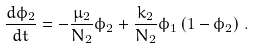<formula> <loc_0><loc_0><loc_500><loc_500>\frac { d \phi _ { 2 } } { d t } = - \frac { \mu _ { 2 } } { N _ { 2 } } \phi _ { 2 } + \frac { k _ { 2 } } { N _ { 2 } } \phi _ { 1 } \left ( 1 - \phi _ { 2 } \right ) \, .</formula> 